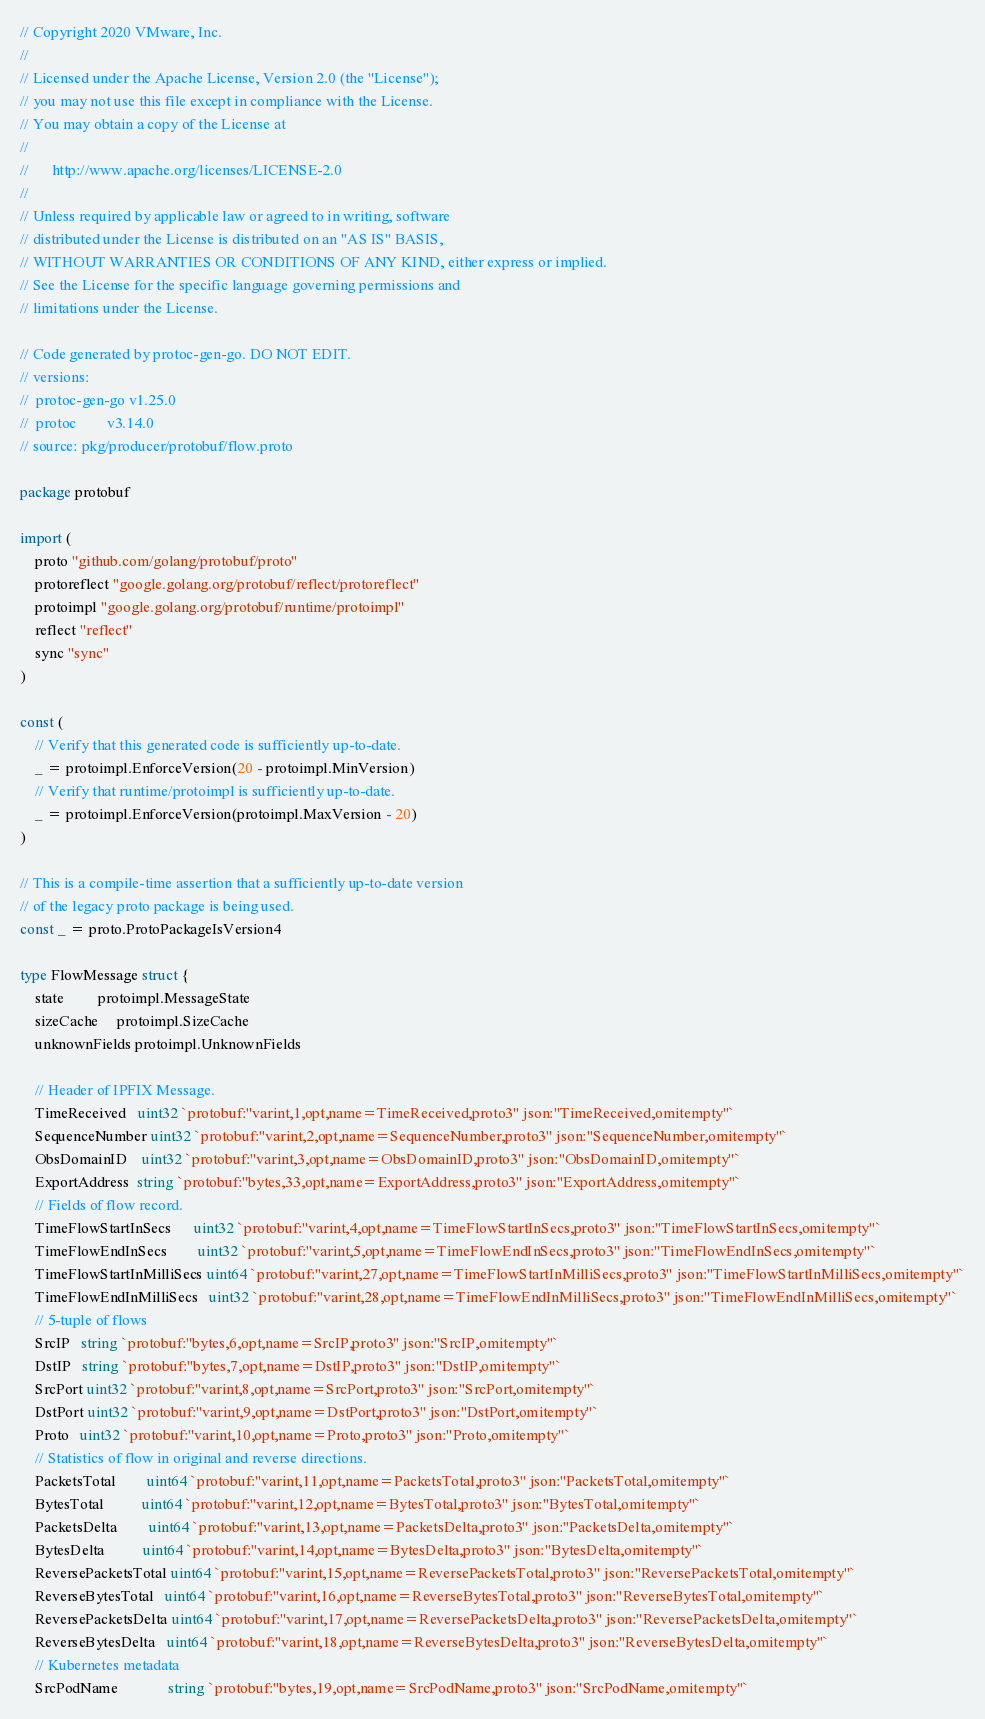Convert code to text. <code><loc_0><loc_0><loc_500><loc_500><_Go_>// Copyright 2020 VMware, Inc.
//
// Licensed under the Apache License, Version 2.0 (the "License");
// you may not use this file except in compliance with the License.
// You may obtain a copy of the License at
//
//      http://www.apache.org/licenses/LICENSE-2.0
//
// Unless required by applicable law or agreed to in writing, software
// distributed under the License is distributed on an "AS IS" BASIS,
// WITHOUT WARRANTIES OR CONDITIONS OF ANY KIND, either express or implied.
// See the License for the specific language governing permissions and
// limitations under the License.

// Code generated by protoc-gen-go. DO NOT EDIT.
// versions:
// 	protoc-gen-go v1.25.0
// 	protoc        v3.14.0
// source: pkg/producer/protobuf/flow.proto

package protobuf

import (
	proto "github.com/golang/protobuf/proto"
	protoreflect "google.golang.org/protobuf/reflect/protoreflect"
	protoimpl "google.golang.org/protobuf/runtime/protoimpl"
	reflect "reflect"
	sync "sync"
)

const (
	// Verify that this generated code is sufficiently up-to-date.
	_ = protoimpl.EnforceVersion(20 - protoimpl.MinVersion)
	// Verify that runtime/protoimpl is sufficiently up-to-date.
	_ = protoimpl.EnforceVersion(protoimpl.MaxVersion - 20)
)

// This is a compile-time assertion that a sufficiently up-to-date version
// of the legacy proto package is being used.
const _ = proto.ProtoPackageIsVersion4

type FlowMessage struct {
	state         protoimpl.MessageState
	sizeCache     protoimpl.SizeCache
	unknownFields protoimpl.UnknownFields

	// Header of IPFIX Message.
	TimeReceived   uint32 `protobuf:"varint,1,opt,name=TimeReceived,proto3" json:"TimeReceived,omitempty"`
	SequenceNumber uint32 `protobuf:"varint,2,opt,name=SequenceNumber,proto3" json:"SequenceNumber,omitempty"`
	ObsDomainID    uint32 `protobuf:"varint,3,opt,name=ObsDomainID,proto3" json:"ObsDomainID,omitempty"`
	ExportAddress  string `protobuf:"bytes,33,opt,name=ExportAddress,proto3" json:"ExportAddress,omitempty"`
	// Fields of flow record.
	TimeFlowStartInSecs      uint32 `protobuf:"varint,4,opt,name=TimeFlowStartInSecs,proto3" json:"TimeFlowStartInSecs,omitempty"`
	TimeFlowEndInSecs        uint32 `protobuf:"varint,5,opt,name=TimeFlowEndInSecs,proto3" json:"TimeFlowEndInSecs,omitempty"`
	TimeFlowStartInMilliSecs uint64 `protobuf:"varint,27,opt,name=TimeFlowStartInMilliSecs,proto3" json:"TimeFlowStartInMilliSecs,omitempty"`
	TimeFlowEndInMilliSecs   uint32 `protobuf:"varint,28,opt,name=TimeFlowEndInMilliSecs,proto3" json:"TimeFlowEndInMilliSecs,omitempty"`
	// 5-tuple of flows
	SrcIP   string `protobuf:"bytes,6,opt,name=SrcIP,proto3" json:"SrcIP,omitempty"`
	DstIP   string `protobuf:"bytes,7,opt,name=DstIP,proto3" json:"DstIP,omitempty"`
	SrcPort uint32 `protobuf:"varint,8,opt,name=SrcPort,proto3" json:"SrcPort,omitempty"`
	DstPort uint32 `protobuf:"varint,9,opt,name=DstPort,proto3" json:"DstPort,omitempty"`
	Proto   uint32 `protobuf:"varint,10,opt,name=Proto,proto3" json:"Proto,omitempty"`
	// Statistics of flow in original and reverse directions.
	PacketsTotal        uint64 `protobuf:"varint,11,opt,name=PacketsTotal,proto3" json:"PacketsTotal,omitempty"`
	BytesTotal          uint64 `protobuf:"varint,12,opt,name=BytesTotal,proto3" json:"BytesTotal,omitempty"`
	PacketsDelta        uint64 `protobuf:"varint,13,opt,name=PacketsDelta,proto3" json:"PacketsDelta,omitempty"`
	BytesDelta          uint64 `protobuf:"varint,14,opt,name=BytesDelta,proto3" json:"BytesDelta,omitempty"`
	ReversePacketsTotal uint64 `protobuf:"varint,15,opt,name=ReversePacketsTotal,proto3" json:"ReversePacketsTotal,omitempty"`
	ReverseBytesTotal   uint64 `protobuf:"varint,16,opt,name=ReverseBytesTotal,proto3" json:"ReverseBytesTotal,omitempty"`
	ReversePacketsDelta uint64 `protobuf:"varint,17,opt,name=ReversePacketsDelta,proto3" json:"ReversePacketsDelta,omitempty"`
	ReverseBytesDelta   uint64 `protobuf:"varint,18,opt,name=ReverseBytesDelta,proto3" json:"ReverseBytesDelta,omitempty"`
	// Kubernetes metadata
	SrcPodName             string `protobuf:"bytes,19,opt,name=SrcPodName,proto3" json:"SrcPodName,omitempty"`</code> 